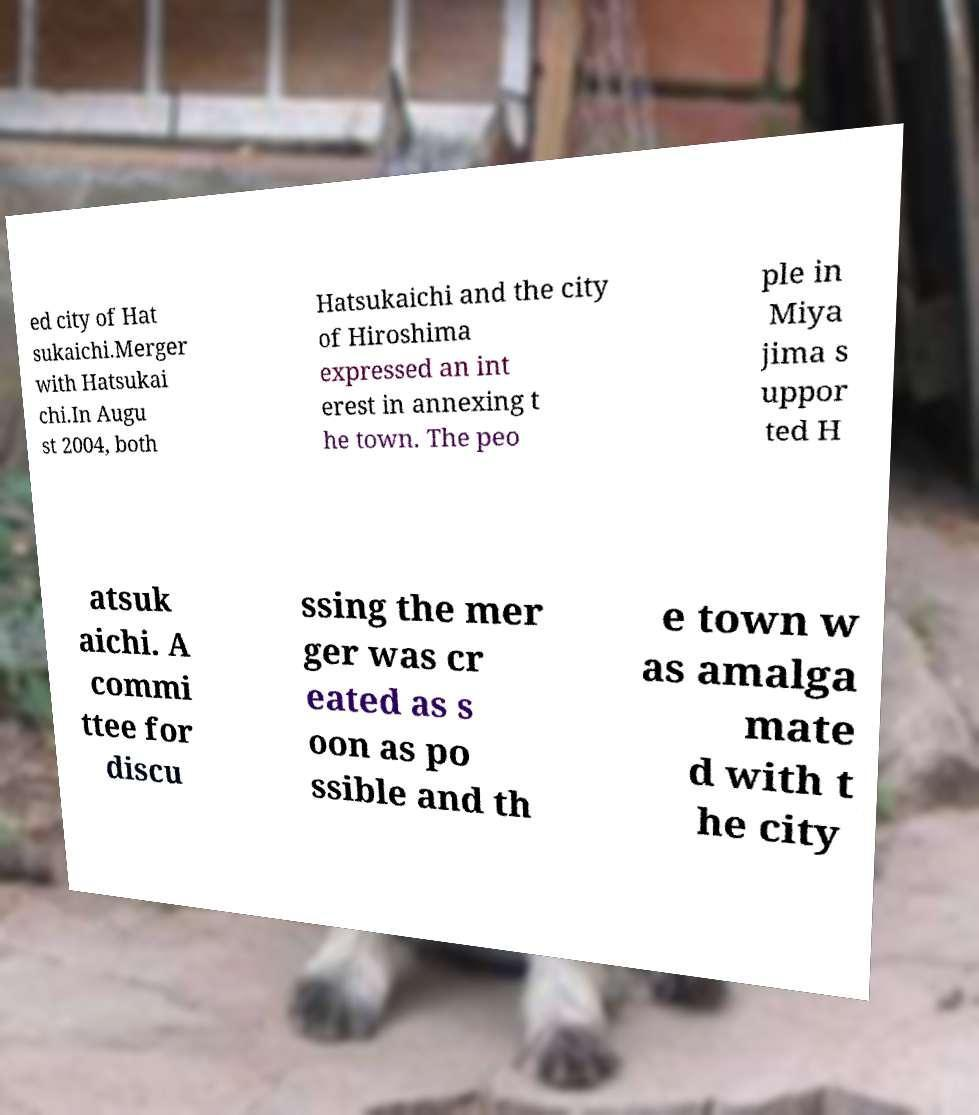Could you extract and type out the text from this image? ed city of Hat sukaichi.Merger with Hatsukai chi.In Augu st 2004, both Hatsukaichi and the city of Hiroshima expressed an int erest in annexing t he town. The peo ple in Miya jima s uppor ted H atsuk aichi. A commi ttee for discu ssing the mer ger was cr eated as s oon as po ssible and th e town w as amalga mate d with t he city 